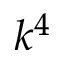Convert formula to latex. <formula><loc_0><loc_0><loc_500><loc_500>k ^ { 4 }</formula> 